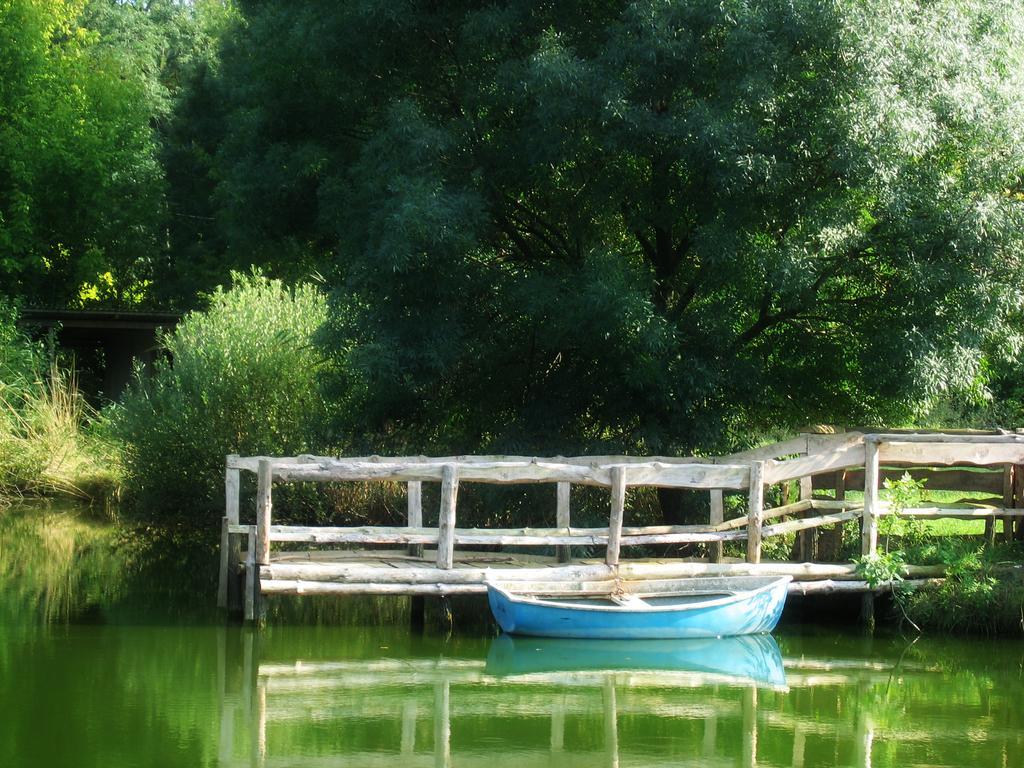Describe this image in one or two sentences. In the picture we can see the water, boat, railing, plants and trees. 